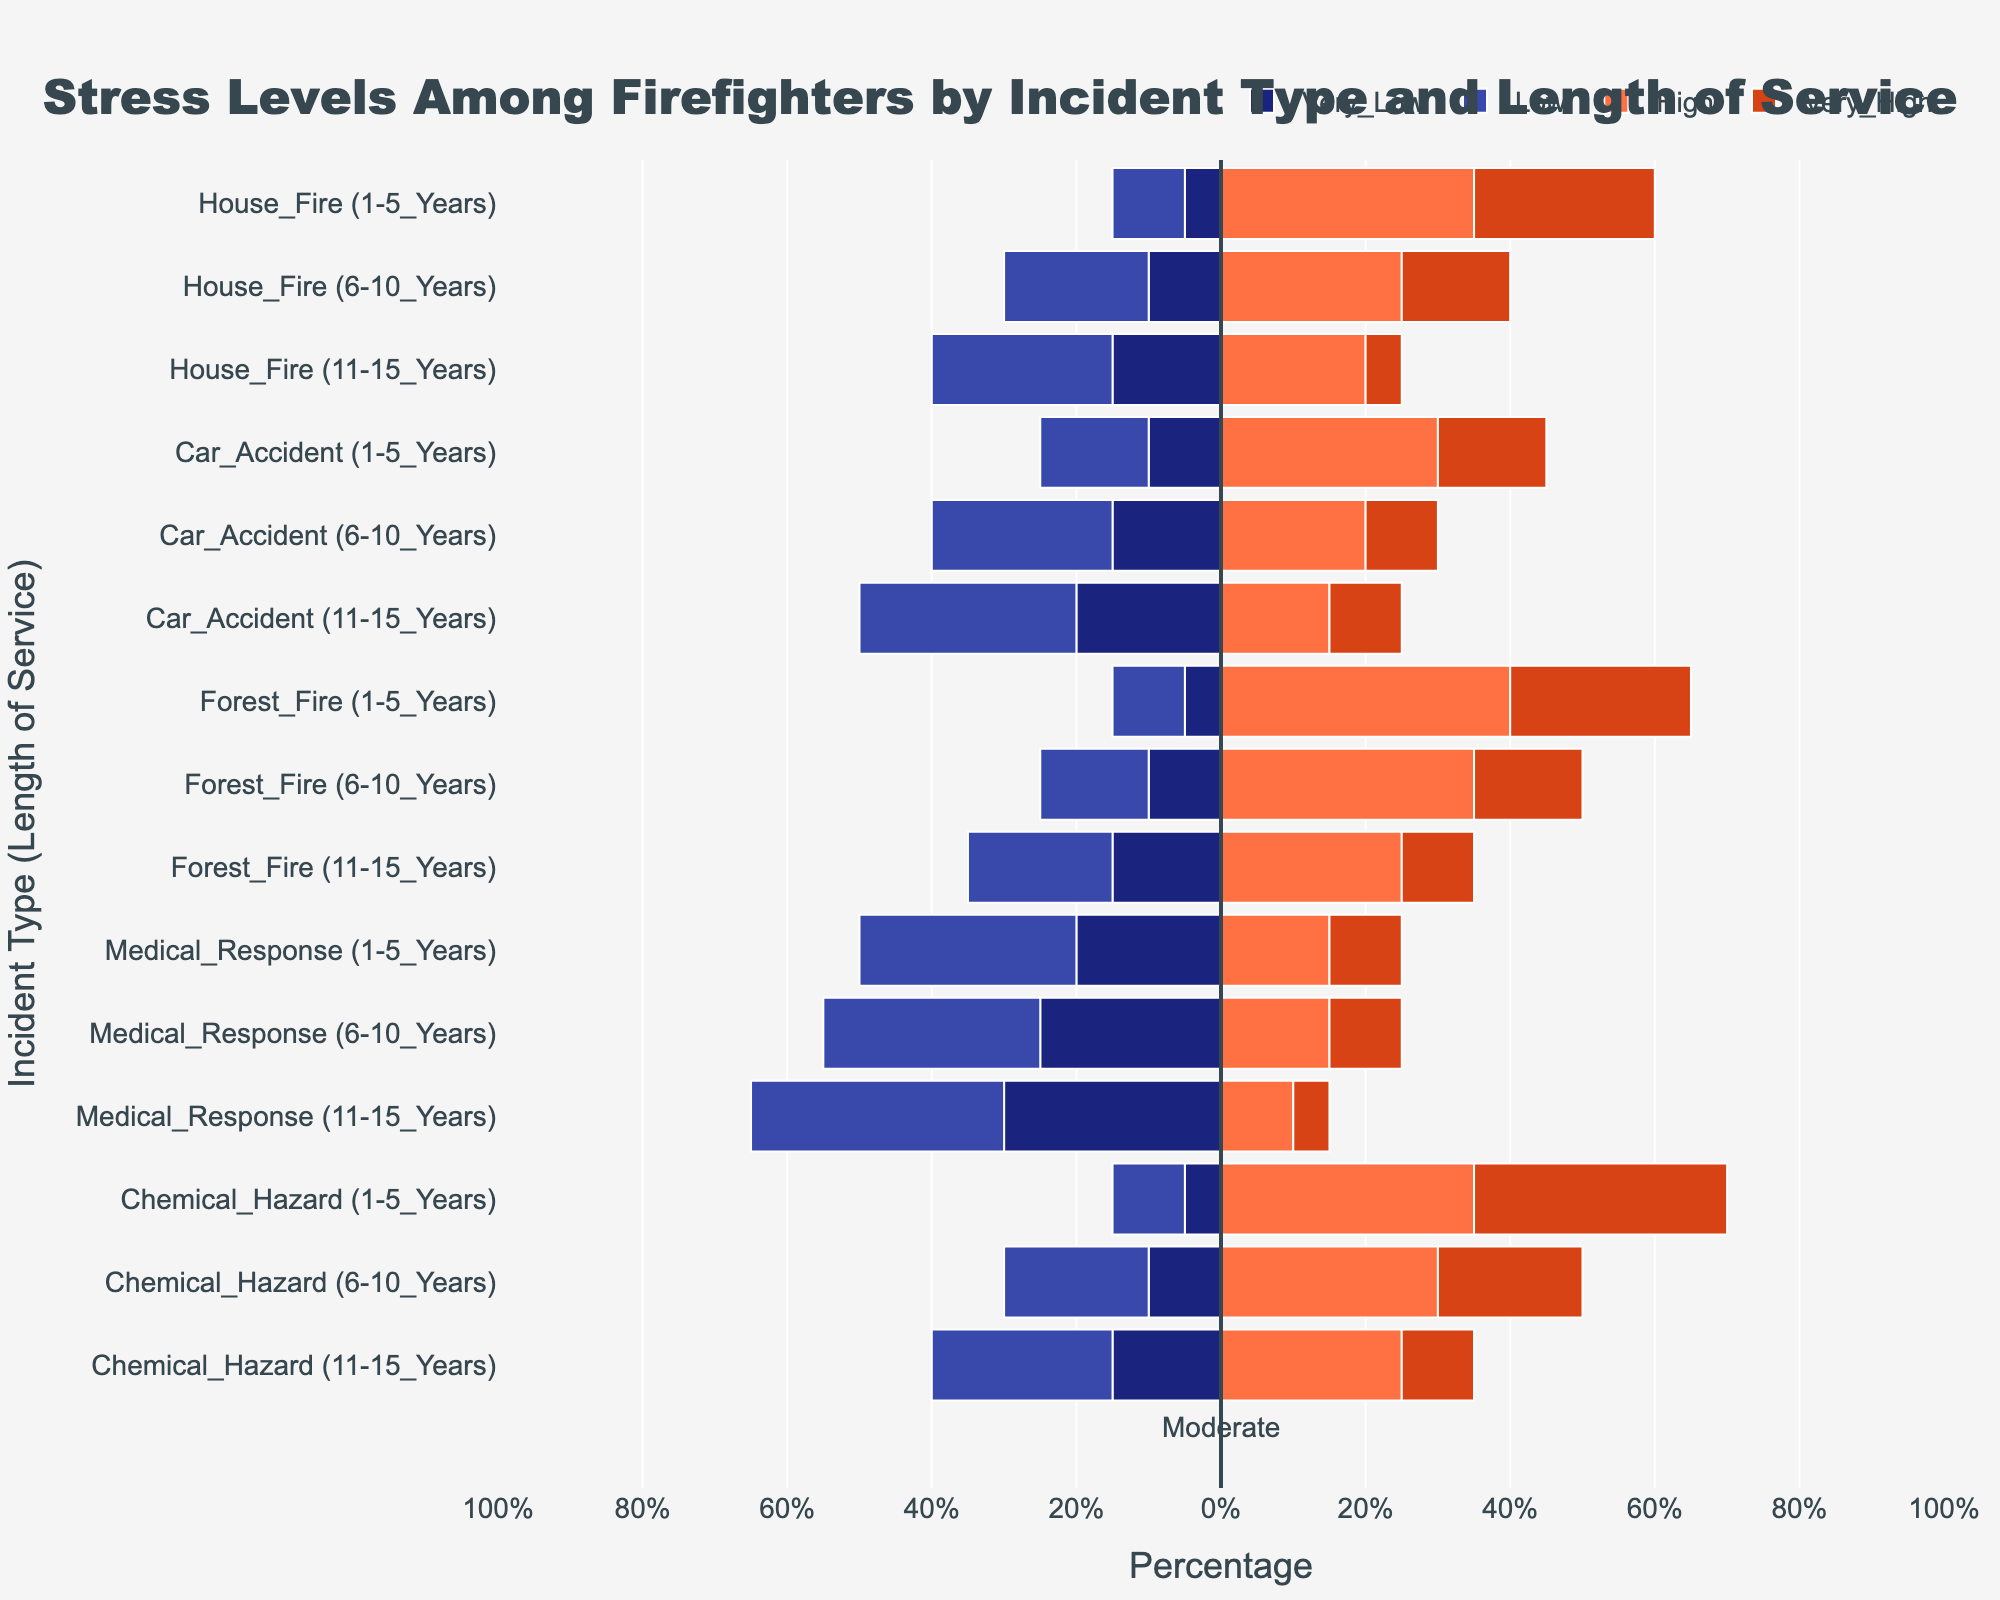What's the overall highest reported stress level among firefighters for the House Fire incident type? For each length of service, check the highest percentage stress level for House Fire. The highest value comes from the 1-5 years group, with 35% reporting high stress.
Answer: 35% Which incident type shows the most "Very High" stress levels for firefighters with 1-5 years of service? Look at the "Very High" percentages for 1-5 years across all incident types. The highest value is 35% for Chemical Hazard.
Answer: Chemical Hazard For the Medical Response incident type, which length of service group reports the least stress at the "Very High" level? Compare the "Very High" stress levels for all lengths of service in Medical Response. The 11-15 years group has the lowest "Very High" level at 5%.
Answer: 11-15 Years Are there more firefighters reporting 'High' stress levels in Forest Fires with 1-5 years of service or 6-10 years of service? Look at the "High" stress percentages for Forest Fires in the 1-5 years and 6-10 years groups. The values are 40% for 1-5 years and 35% for 6-10 years.
Answer: 1-5 Years Which incident type and length of service combination has the smallest percentage of "Very Low" stress levels? Compare the "Very Low" stress percentages across all incident types and service lengths. Medical Response for 1-5 years has the highest "Very Low" percentage of 20%.
Answer: Medical Response (1-5 Years) In the Car Accident incident type, what is the average percentage of "Moderate" stress levels for firefighters with 1-5 years and 6-10 years of service? Add the "Moderate" stress levels for 1-5 years (30%) and 6-10 years (30%), then divide by 2.
Answer: 30% Which incident type has the highest combined percentage of "High" and "Very High" stress levels, regardless of length of service? Sum the "High" and "Very High" stress levels for each incident type and find the highest value. Chemical Hazard has 70% (35% + 35%) in the 1-5 years group.
Answer: Chemical Hazard Is there any incident type where veterans (11-15 years) report less than 10% "Very High" stress levels? Check the "Very High" stress levels for 11-15 years of service across all incident types. House Fire (5%), Car Accident (10%), Forest Fire (10%), Medical Response (5%), Chemical Hazard (10%) all report less than 10%.
Answer: Multiple (House Fire, Medical Response) Comparing Car Accident and Forest Fire incidents, which incident type has a higher percentage of "Low" stress levels for 11-15 years of service? Compare the "Low" stress percentages for Car Accident (30%) and Forest Fire (20%) in the 11-15 years group.
Answer: Car Accident 